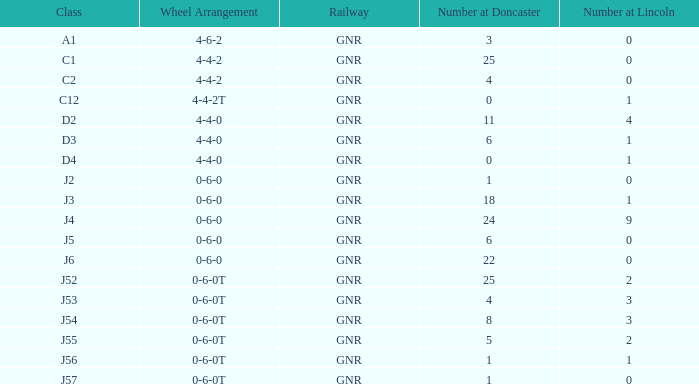Which Class has a Number at Lincoln larger than 0 and a Number at Doncaster of 8? J54. 